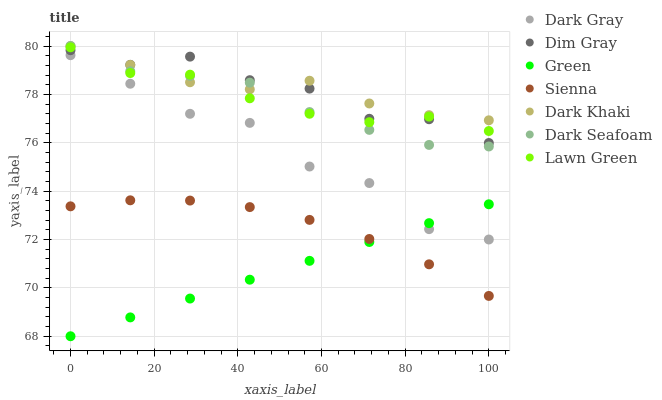Does Green have the minimum area under the curve?
Answer yes or no. Yes. Does Dark Khaki have the maximum area under the curve?
Answer yes or no. Yes. Does Dim Gray have the minimum area under the curve?
Answer yes or no. No. Does Dim Gray have the maximum area under the curve?
Answer yes or no. No. Is Green the smoothest?
Answer yes or no. Yes. Is Dark Gray the roughest?
Answer yes or no. Yes. Is Dim Gray the smoothest?
Answer yes or no. No. Is Dim Gray the roughest?
Answer yes or no. No. Does Green have the lowest value?
Answer yes or no. Yes. Does Dim Gray have the lowest value?
Answer yes or no. No. Does Dark Khaki have the highest value?
Answer yes or no. Yes. Does Dim Gray have the highest value?
Answer yes or no. No. Is Green less than Lawn Green?
Answer yes or no. Yes. Is Dim Gray greater than Sienna?
Answer yes or no. Yes. Does Dim Gray intersect Lawn Green?
Answer yes or no. Yes. Is Dim Gray less than Lawn Green?
Answer yes or no. No. Is Dim Gray greater than Lawn Green?
Answer yes or no. No. Does Green intersect Lawn Green?
Answer yes or no. No. 